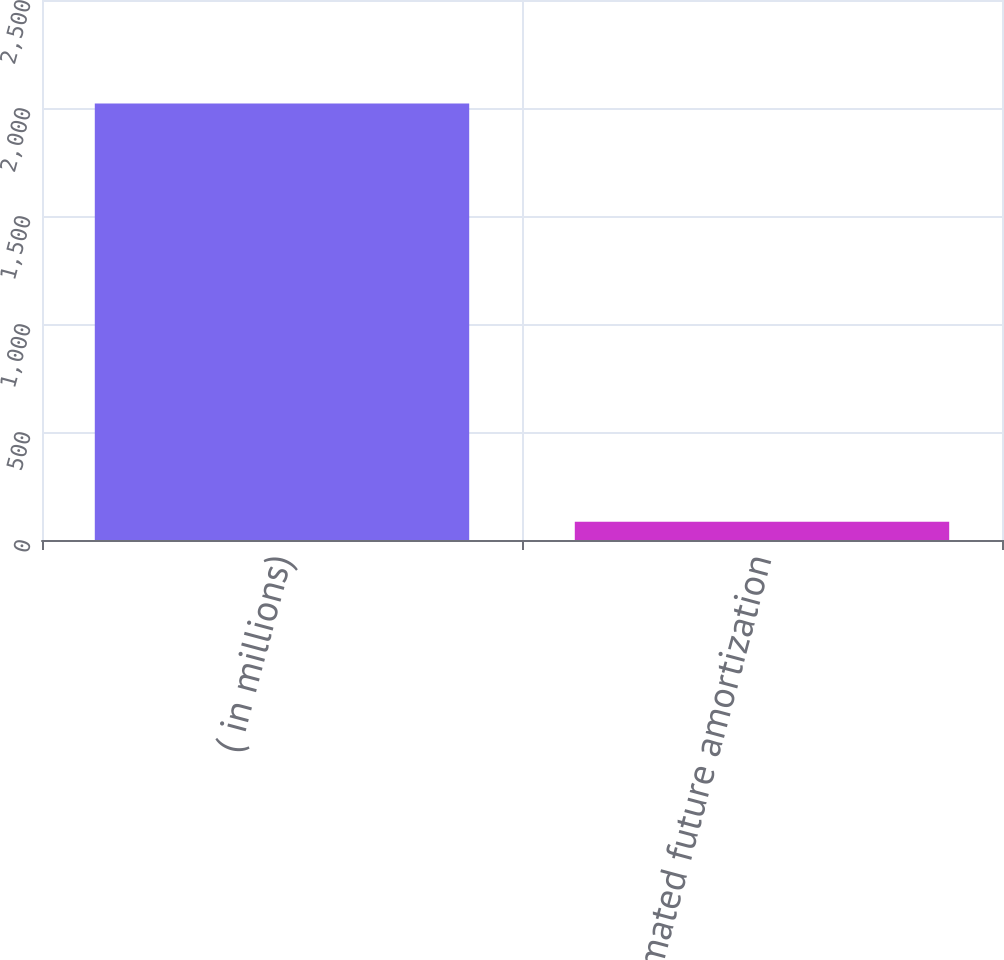<chart> <loc_0><loc_0><loc_500><loc_500><bar_chart><fcel>( in millions)<fcel>Estimated future amortization<nl><fcel>2021<fcel>85<nl></chart> 